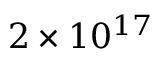<formula> <loc_0><loc_0><loc_500><loc_500>2 \times 1 0 ^ { 1 7 }</formula> 